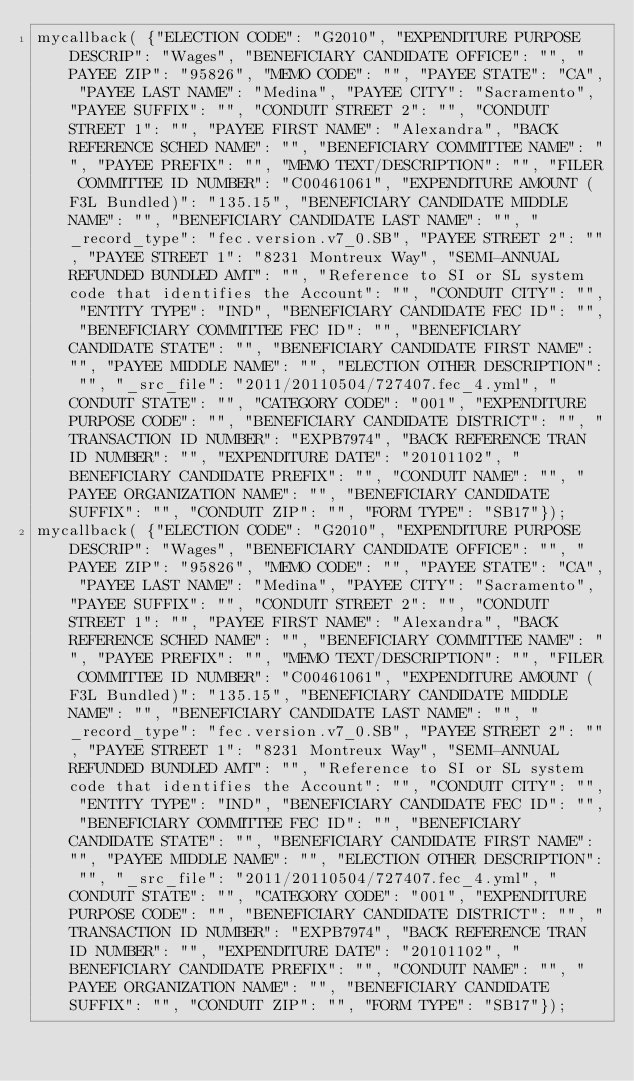<code> <loc_0><loc_0><loc_500><loc_500><_JavaScript_>mycallback( {"ELECTION CODE": "G2010", "EXPENDITURE PURPOSE DESCRIP": "Wages", "BENEFICIARY CANDIDATE OFFICE": "", "PAYEE ZIP": "95826", "MEMO CODE": "", "PAYEE STATE": "CA", "PAYEE LAST NAME": "Medina", "PAYEE CITY": "Sacramento", "PAYEE SUFFIX": "", "CONDUIT STREET 2": "", "CONDUIT STREET 1": "", "PAYEE FIRST NAME": "Alexandra", "BACK REFERENCE SCHED NAME": "", "BENEFICIARY COMMITTEE NAME": "", "PAYEE PREFIX": "", "MEMO TEXT/DESCRIPTION": "", "FILER COMMITTEE ID NUMBER": "C00461061", "EXPENDITURE AMOUNT (F3L Bundled)": "135.15", "BENEFICIARY CANDIDATE MIDDLE NAME": "", "BENEFICIARY CANDIDATE LAST NAME": "", "_record_type": "fec.version.v7_0.SB", "PAYEE STREET 2": "", "PAYEE STREET 1": "8231 Montreux Way", "SEMI-ANNUAL REFUNDED BUNDLED AMT": "", "Reference to SI or SL system code that identifies the Account": "", "CONDUIT CITY": "", "ENTITY TYPE": "IND", "BENEFICIARY CANDIDATE FEC ID": "", "BENEFICIARY COMMITTEE FEC ID": "", "BENEFICIARY CANDIDATE STATE": "", "BENEFICIARY CANDIDATE FIRST NAME": "", "PAYEE MIDDLE NAME": "", "ELECTION OTHER DESCRIPTION": "", "_src_file": "2011/20110504/727407.fec_4.yml", "CONDUIT STATE": "", "CATEGORY CODE": "001", "EXPENDITURE PURPOSE CODE": "", "BENEFICIARY CANDIDATE DISTRICT": "", "TRANSACTION ID NUMBER": "EXPB7974", "BACK REFERENCE TRAN ID NUMBER": "", "EXPENDITURE DATE": "20101102", "BENEFICIARY CANDIDATE PREFIX": "", "CONDUIT NAME": "", "PAYEE ORGANIZATION NAME": "", "BENEFICIARY CANDIDATE SUFFIX": "", "CONDUIT ZIP": "", "FORM TYPE": "SB17"});
mycallback( {"ELECTION CODE": "G2010", "EXPENDITURE PURPOSE DESCRIP": "Wages", "BENEFICIARY CANDIDATE OFFICE": "", "PAYEE ZIP": "95826", "MEMO CODE": "", "PAYEE STATE": "CA", "PAYEE LAST NAME": "Medina", "PAYEE CITY": "Sacramento", "PAYEE SUFFIX": "", "CONDUIT STREET 2": "", "CONDUIT STREET 1": "", "PAYEE FIRST NAME": "Alexandra", "BACK REFERENCE SCHED NAME": "", "BENEFICIARY COMMITTEE NAME": "", "PAYEE PREFIX": "", "MEMO TEXT/DESCRIPTION": "", "FILER COMMITTEE ID NUMBER": "C00461061", "EXPENDITURE AMOUNT (F3L Bundled)": "135.15", "BENEFICIARY CANDIDATE MIDDLE NAME": "", "BENEFICIARY CANDIDATE LAST NAME": "", "_record_type": "fec.version.v7_0.SB", "PAYEE STREET 2": "", "PAYEE STREET 1": "8231 Montreux Way", "SEMI-ANNUAL REFUNDED BUNDLED AMT": "", "Reference to SI or SL system code that identifies the Account": "", "CONDUIT CITY": "", "ENTITY TYPE": "IND", "BENEFICIARY CANDIDATE FEC ID": "", "BENEFICIARY COMMITTEE FEC ID": "", "BENEFICIARY CANDIDATE STATE": "", "BENEFICIARY CANDIDATE FIRST NAME": "", "PAYEE MIDDLE NAME": "", "ELECTION OTHER DESCRIPTION": "", "_src_file": "2011/20110504/727407.fec_4.yml", "CONDUIT STATE": "", "CATEGORY CODE": "001", "EXPENDITURE PURPOSE CODE": "", "BENEFICIARY CANDIDATE DISTRICT": "", "TRANSACTION ID NUMBER": "EXPB7974", "BACK REFERENCE TRAN ID NUMBER": "", "EXPENDITURE DATE": "20101102", "BENEFICIARY CANDIDATE PREFIX": "", "CONDUIT NAME": "", "PAYEE ORGANIZATION NAME": "", "BENEFICIARY CANDIDATE SUFFIX": "", "CONDUIT ZIP": "", "FORM TYPE": "SB17"});
</code> 